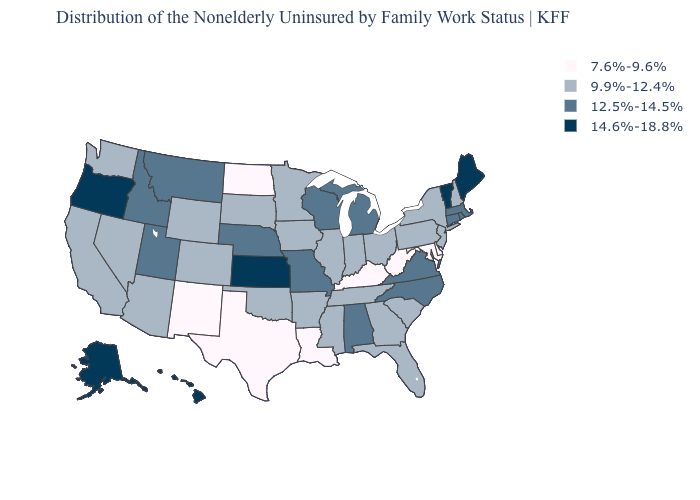What is the value of Mississippi?
Write a very short answer. 9.9%-12.4%. What is the value of West Virginia?
Answer briefly. 7.6%-9.6%. Among the states that border New Mexico , does Utah have the highest value?
Be succinct. Yes. What is the value of Florida?
Answer briefly. 9.9%-12.4%. What is the value of West Virginia?
Short answer required. 7.6%-9.6%. Does Iowa have a lower value than New York?
Write a very short answer. No. Name the states that have a value in the range 7.6%-9.6%?
Give a very brief answer. Delaware, Kentucky, Louisiana, Maryland, New Mexico, North Dakota, Texas, West Virginia. Among the states that border South Dakota , which have the highest value?
Be succinct. Montana, Nebraska. Does Alaska have a lower value than Minnesota?
Keep it brief. No. What is the highest value in states that border Iowa?
Keep it brief. 12.5%-14.5%. Does the map have missing data?
Write a very short answer. No. What is the highest value in states that border West Virginia?
Write a very short answer. 12.5%-14.5%. Name the states that have a value in the range 14.6%-18.8%?
Quick response, please. Alaska, Hawaii, Kansas, Maine, Oregon, Vermont. What is the highest value in states that border West Virginia?
Quick response, please. 12.5%-14.5%. What is the value of Hawaii?
Keep it brief. 14.6%-18.8%. 